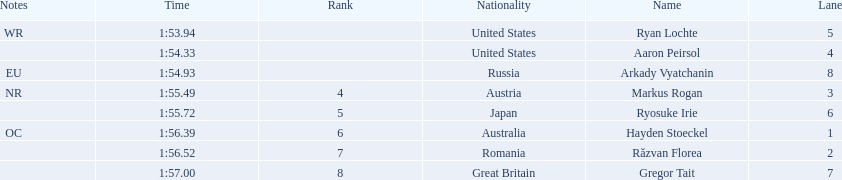What is the name of the contestant in lane 6? Ryosuke Irie. Parse the full table in json format. {'header': ['Notes', 'Time', 'Rank', 'Nationality', 'Name', 'Lane'], 'rows': [['WR', '1:53.94', '', 'United States', 'Ryan Lochte', '5'], ['', '1:54.33', '', 'United States', 'Aaron Peirsol', '4'], ['EU', '1:54.93', '', 'Russia', 'Arkady Vyatchanin', '8'], ['NR', '1:55.49', '4', 'Austria', 'Markus Rogan', '3'], ['', '1:55.72', '5', 'Japan', 'Ryosuke Irie', '6'], ['OC', '1:56.39', '6', 'Australia', 'Hayden Stoeckel', '1'], ['', '1:56.52', '7', 'Romania', 'Răzvan Florea', '2'], ['', '1:57.00', '8', 'Great Britain', 'Gregor Tait', '7']]} How long did it take that player to complete the race? 1:55.72. 